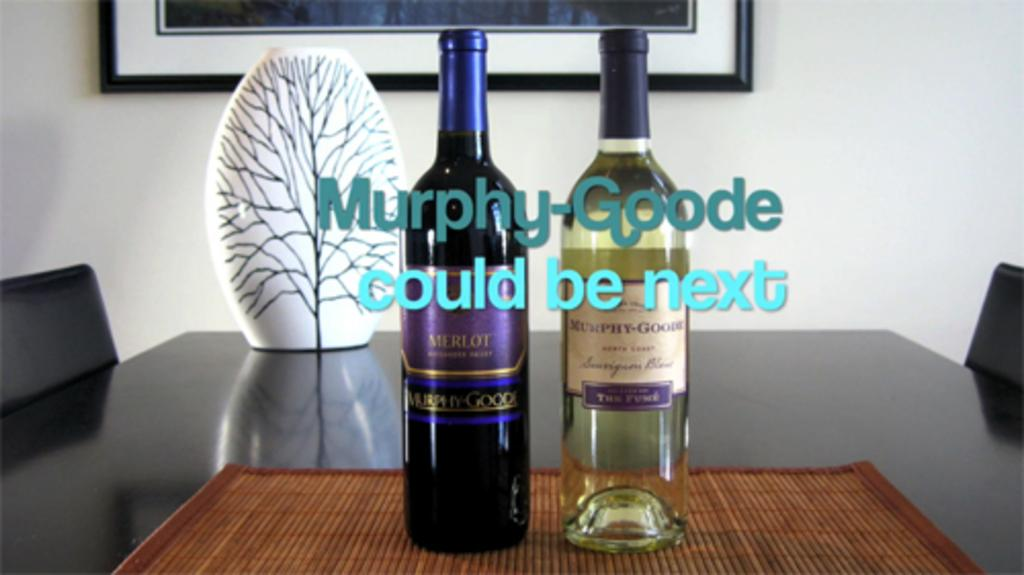<image>
Provide a brief description of the given image. Bottles of alcohol with one that has a label which says "Myrphy-Goode". 